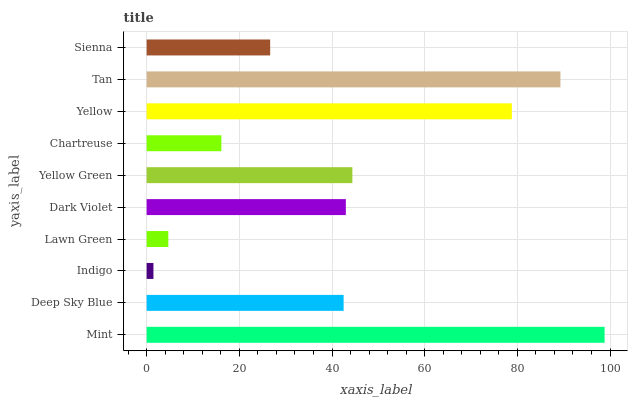Is Indigo the minimum?
Answer yes or no. Yes. Is Mint the maximum?
Answer yes or no. Yes. Is Deep Sky Blue the minimum?
Answer yes or no. No. Is Deep Sky Blue the maximum?
Answer yes or no. No. Is Mint greater than Deep Sky Blue?
Answer yes or no. Yes. Is Deep Sky Blue less than Mint?
Answer yes or no. Yes. Is Deep Sky Blue greater than Mint?
Answer yes or no. No. Is Mint less than Deep Sky Blue?
Answer yes or no. No. Is Dark Violet the high median?
Answer yes or no. Yes. Is Deep Sky Blue the low median?
Answer yes or no. Yes. Is Yellow Green the high median?
Answer yes or no. No. Is Mint the low median?
Answer yes or no. No. 